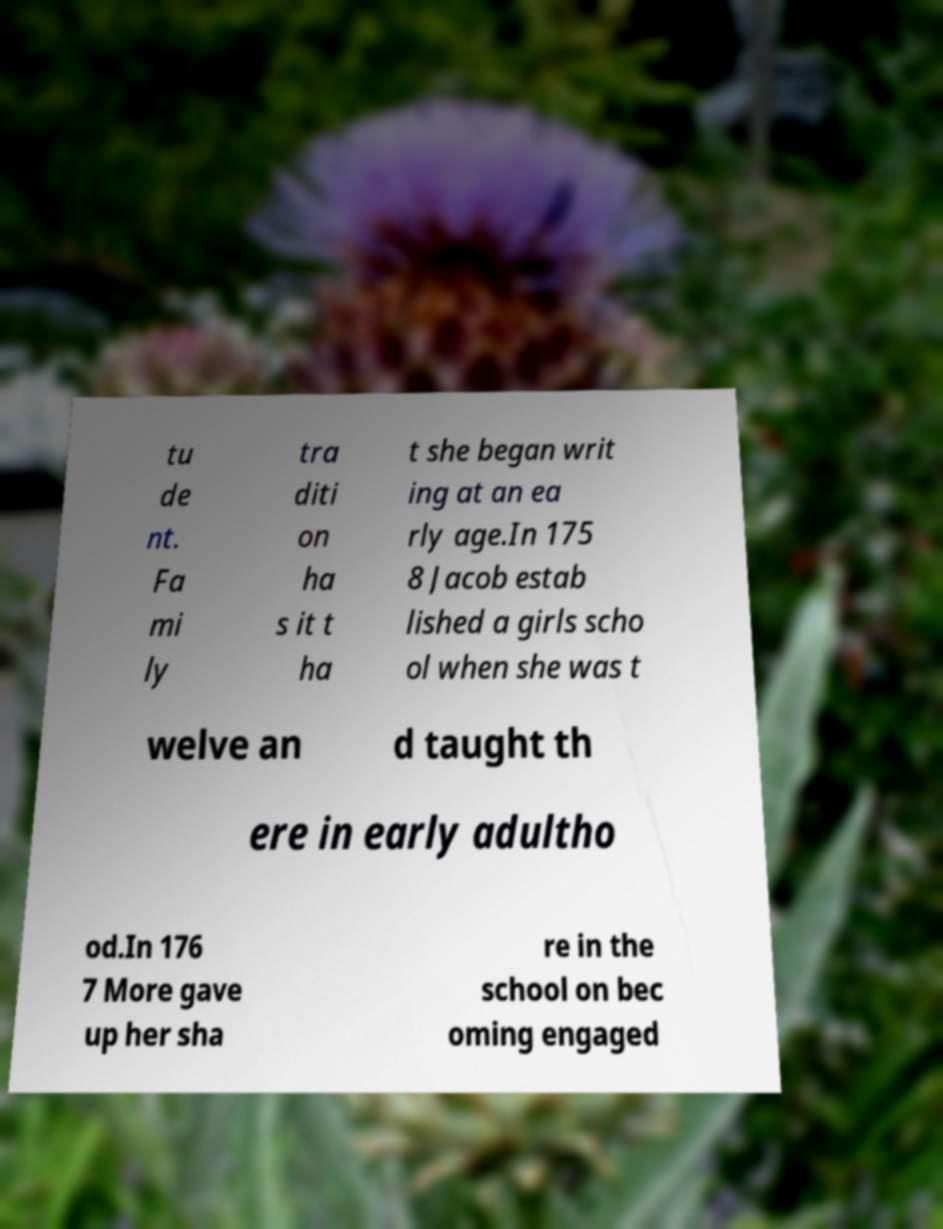For documentation purposes, I need the text within this image transcribed. Could you provide that? tu de nt. Fa mi ly tra diti on ha s it t ha t she began writ ing at an ea rly age.In 175 8 Jacob estab lished a girls scho ol when she was t welve an d taught th ere in early adultho od.In 176 7 More gave up her sha re in the school on bec oming engaged 